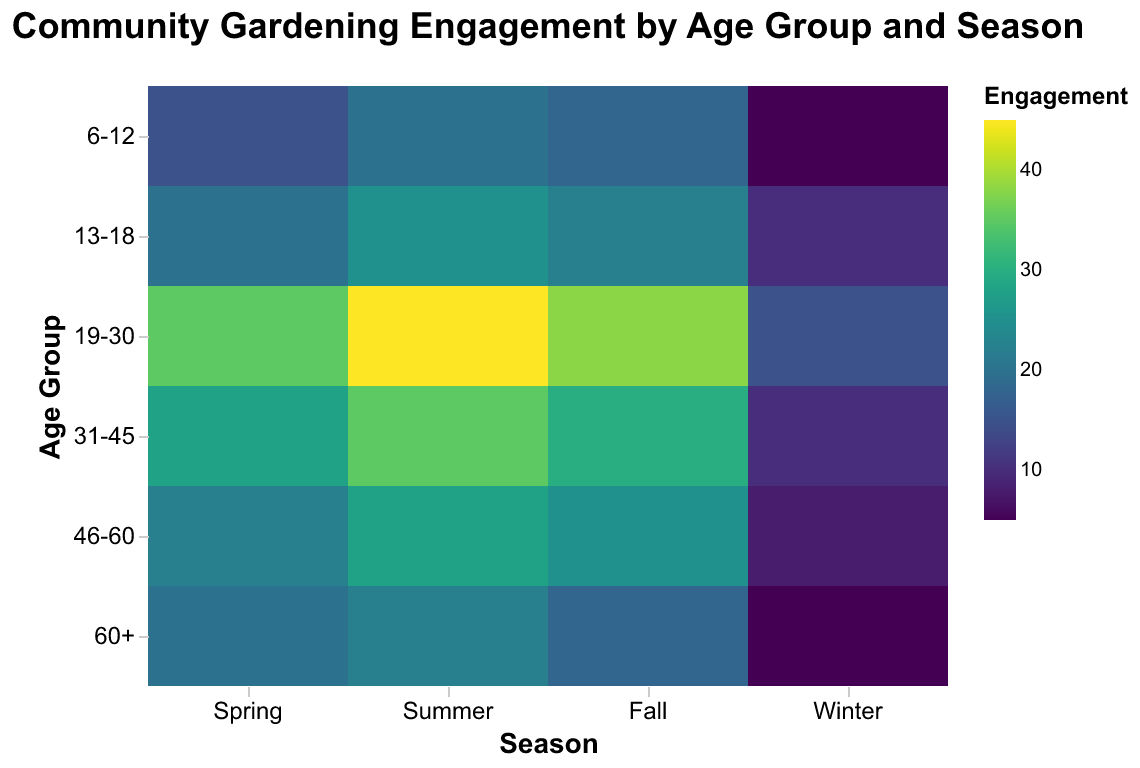How many age groups are represented in the figure? Count the unique age groups on the y-axis; they are 6-12, 13-18, 19-30, 31-45, 46-60, and 60+. So, there are 6 age groups.
Answer: 6 Which season shows the highest engagement level for the 19-30 age group? Look at the heatmap color intensity for the 19-30 age group across all seasons. The color is darkest in the Summer, indicating the highest engagement level of 45.
Answer: Summer What is the engagement level for the 60+ age group during Winter? Locate the cell corresponding to the 60+ age group and Winter season on the heatmap. The value in that cell is 5.
Answer: 5 Which age group has the overall highest engagement level, and in which season? Compare the darkest cells across all age groups and seasons. The 19-30 age group in Summer has the darkest color with an engagement level of 45.
Answer: 19-30 in Summer What is the difference in engagement levels between Spring and Winter for the 46-60 age group? Subtract the engagement level in Winter (8) from that in Spring (22) for the 46-60 age group to get the difference: 22 - 8 = 14.
Answer: 14 Which age group has the lowest engagement in the Fall season? Identify the lightest cell color in the Fall column. The 6-12 and 60+ age groups both have the same engagement level of 18.
Answer: 6-12 and 60+ What is the average engagement level for the 31-45 age group across all seasons? Sum the engagement levels for 31-45 (28, 35, 30, 10) and divide by 4: (28 + 35 + 30 + 10) / 4 = 103 / 4 = 25.75.
Answer: 25.75 Which season generally appears to have the highest engagement levels across all age groups? Observe the overall color intensity in each column. The Summer season consistently has the darkest cells, indicating the highest engagement levels overall.
Answer: Summer What is the trend of engagement levels for the 13-18 age group across the seasons? Observe the 13-18 row in the heatmap. Engagement increases from Spring (20) to Summer (25), slightly decreases in Fall (22), then drops significantly in Winter (10).
Answer: Increases, then decreases Comparing the engagement levels between the 19-30 and 31-45 age groups in the Fall season, which one is higher? Locate the Fall season for both 19-30 (38) and 31-45 (30). The 19-30 age group has a higher engagement level of 38.
Answer: 19-30 